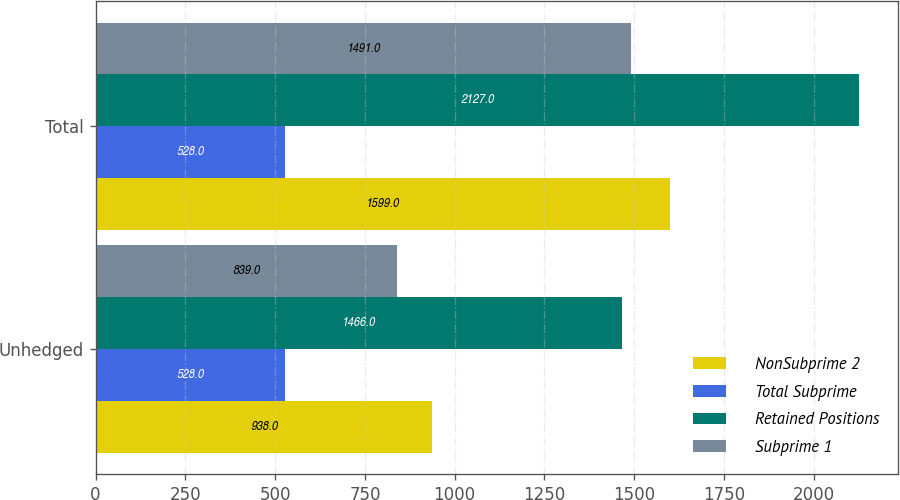<chart> <loc_0><loc_0><loc_500><loc_500><stacked_bar_chart><ecel><fcel>Unhedged<fcel>Total<nl><fcel>NonSubprime 2<fcel>938<fcel>1599<nl><fcel>Total Subprime<fcel>528<fcel>528<nl><fcel>Retained Positions<fcel>1466<fcel>2127<nl><fcel>Subprime 1<fcel>839<fcel>1491<nl></chart> 